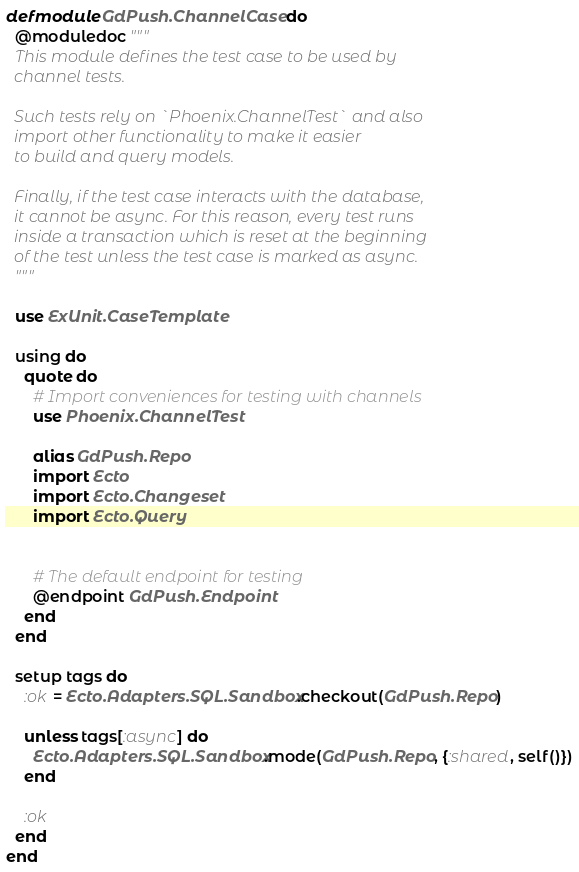<code> <loc_0><loc_0><loc_500><loc_500><_Elixir_>defmodule GdPush.ChannelCase do
  @moduledoc """
  This module defines the test case to be used by
  channel tests.

  Such tests rely on `Phoenix.ChannelTest` and also
  import other functionality to make it easier
  to build and query models.

  Finally, if the test case interacts with the database,
  it cannot be async. For this reason, every test runs
  inside a transaction which is reset at the beginning
  of the test unless the test case is marked as async.
  """

  use ExUnit.CaseTemplate

  using do
    quote do
      # Import conveniences for testing with channels
      use Phoenix.ChannelTest

      alias GdPush.Repo
      import Ecto
      import Ecto.Changeset
      import Ecto.Query


      # The default endpoint for testing
      @endpoint GdPush.Endpoint
    end
  end

  setup tags do
    :ok = Ecto.Adapters.SQL.Sandbox.checkout(GdPush.Repo)

    unless tags[:async] do
      Ecto.Adapters.SQL.Sandbox.mode(GdPush.Repo, {:shared, self()})
    end

    :ok
  end
end
</code> 